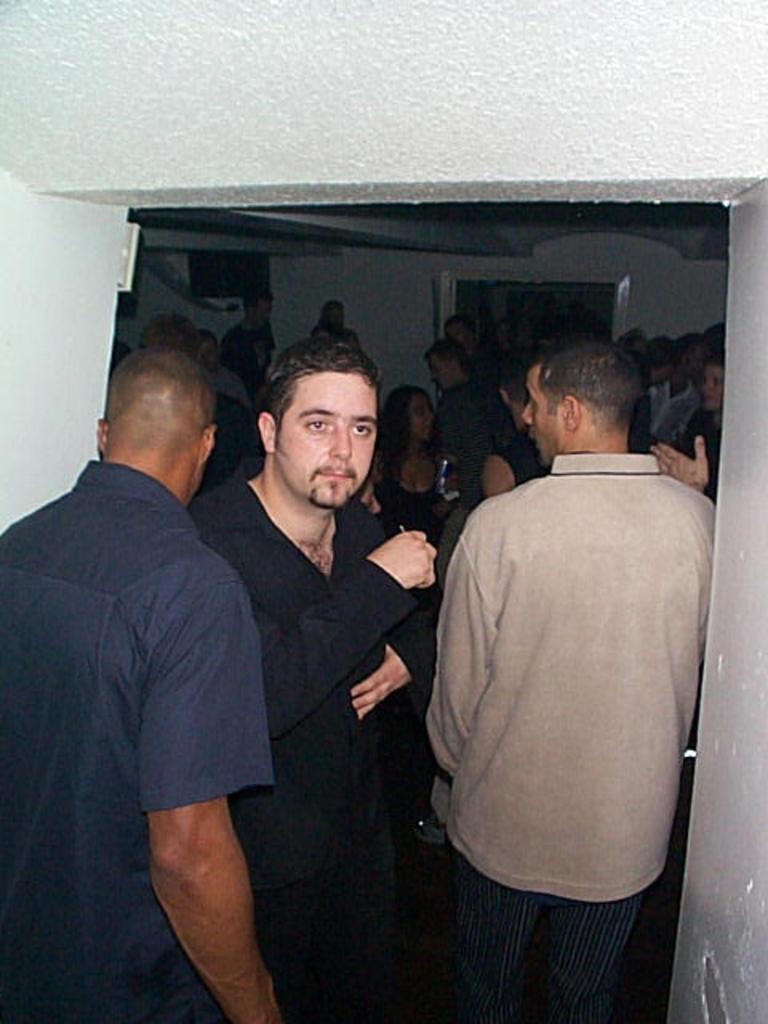What type of setting is depicted in the image? The image shows an interior view of a building. Can you describe the people in the image? There is a group of people standing on the floor. What architectural feature can be seen in the background? There is a door visible in the background. Are there any other structural elements in the background? Yes, there are pillars in the background. What type of comfort can be found on the edge of the building in the image? There is no mention of an edge or comfort in the image; it shows an interior view of a building with a group of people standing on the floor and a door and pillars in the background. 